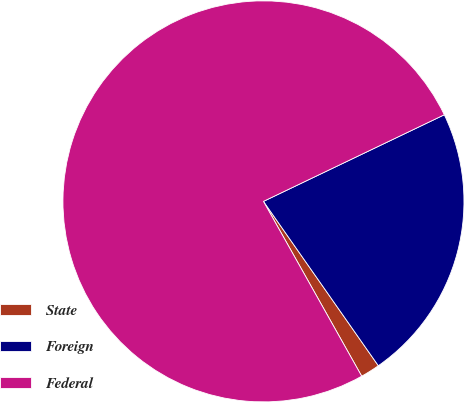<chart> <loc_0><loc_0><loc_500><loc_500><pie_chart><fcel>State<fcel>Foreign<fcel>Federal<nl><fcel>1.56%<fcel>22.4%<fcel>76.04%<nl></chart> 